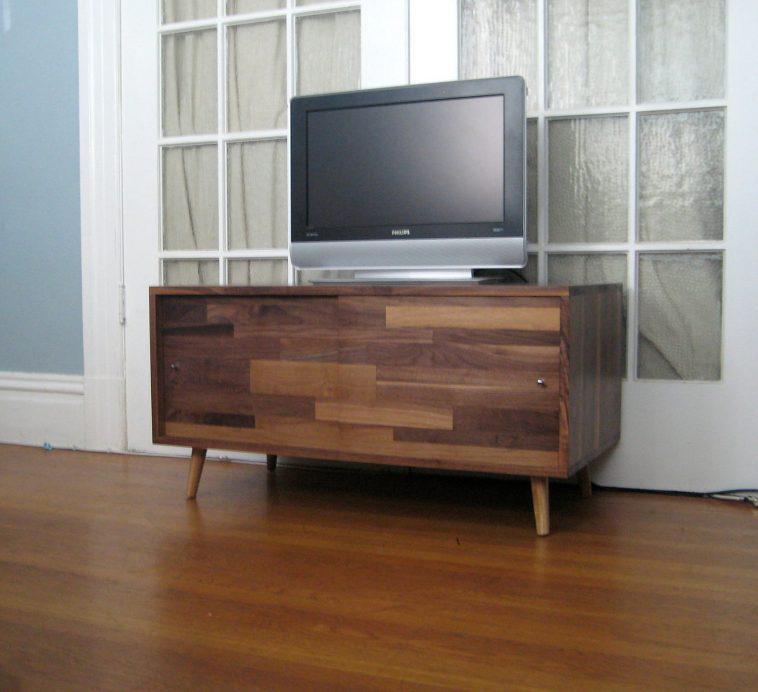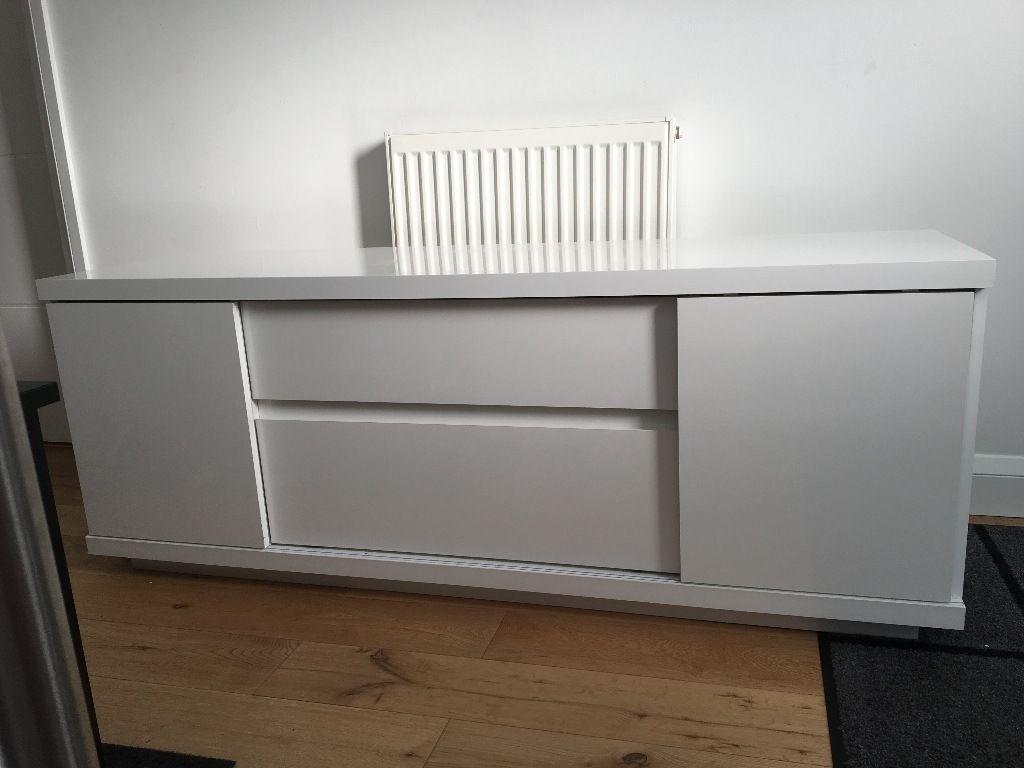The first image is the image on the left, the second image is the image on the right. For the images displayed, is the sentence "In 1 of the images, 1 cabinet on a solid floor has a door opened in the front." factually correct? Answer yes or no. No. The first image is the image on the left, the second image is the image on the right. Assess this claim about the two images: "Two low, wide wooden shelving units are different colors and different designs.". Correct or not? Answer yes or no. Yes. 